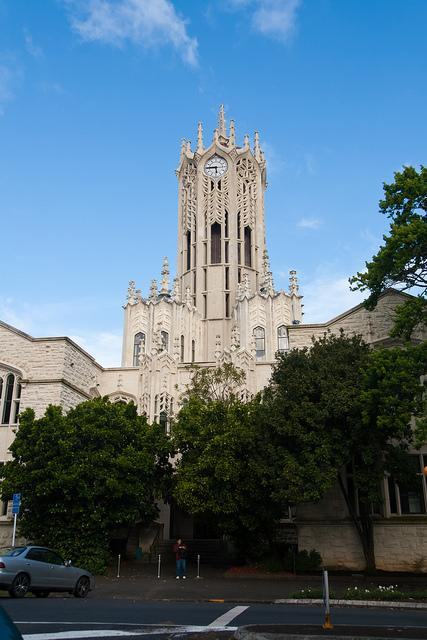What country is this building in? Please explain your reasoning. australia. The country is australia. 